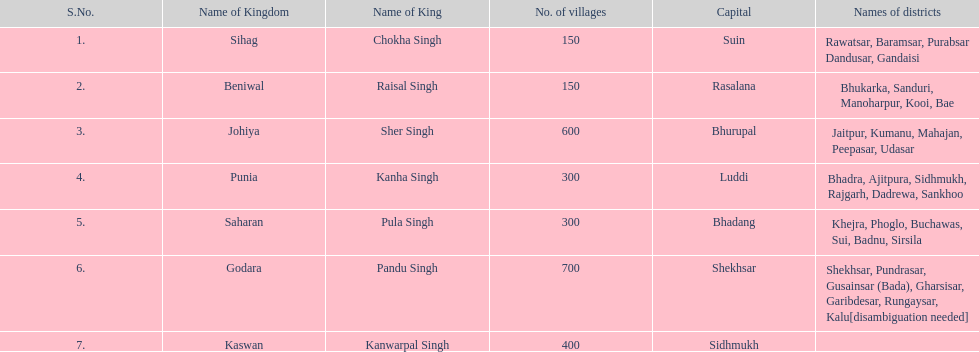Which has a higher number of villages: punia or godara? Less. 